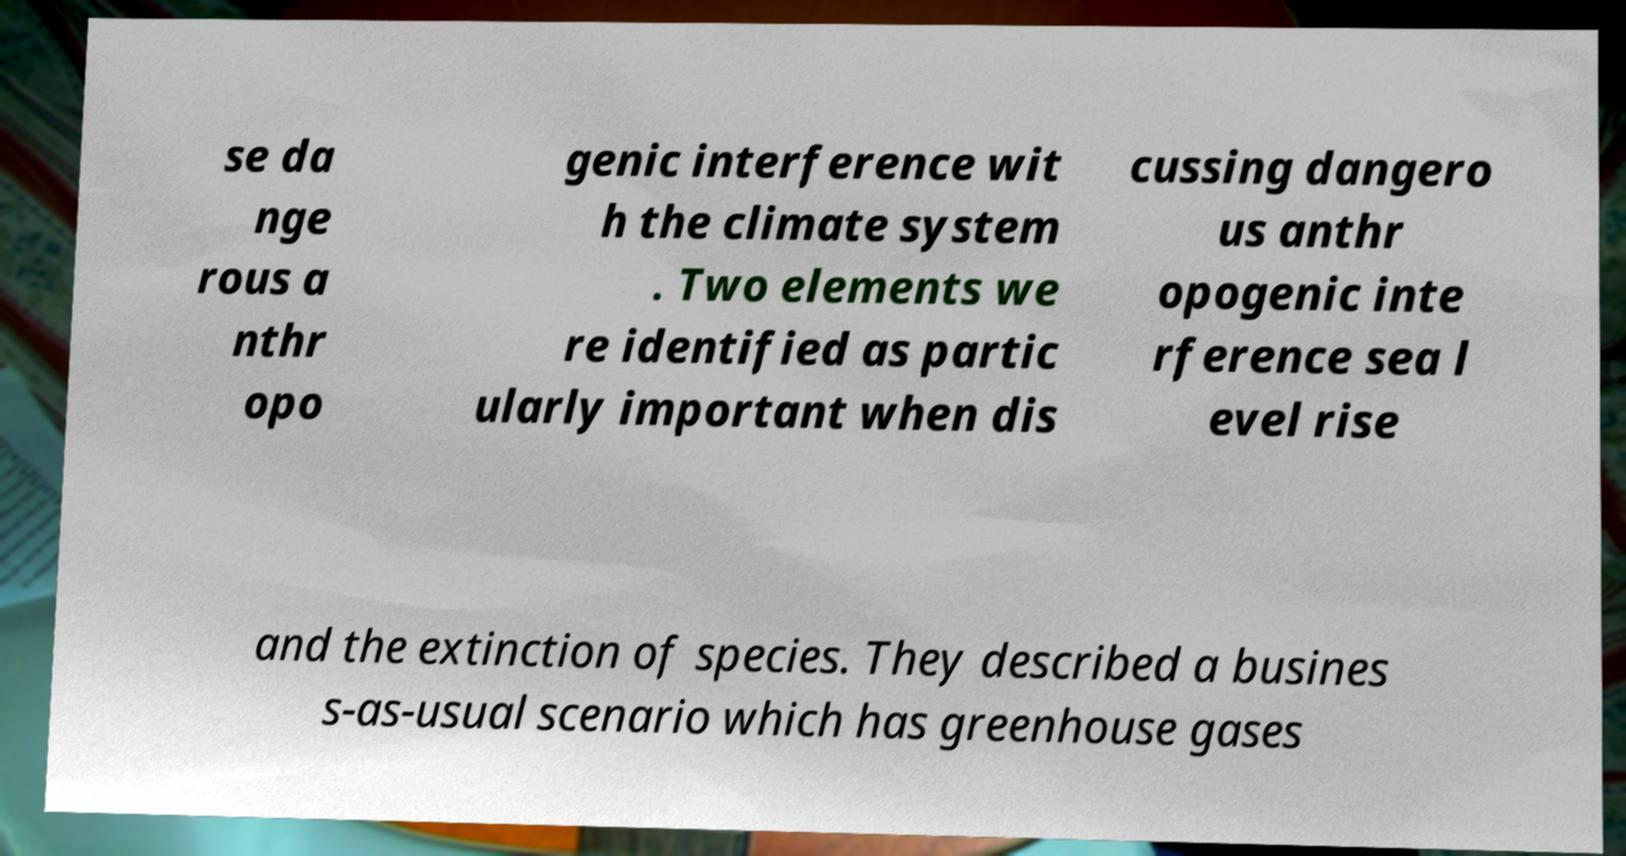What messages or text are displayed in this image? I need them in a readable, typed format. se da nge rous a nthr opo genic interference wit h the climate system . Two elements we re identified as partic ularly important when dis cussing dangero us anthr opogenic inte rference sea l evel rise and the extinction of species. They described a busines s-as-usual scenario which has greenhouse gases 